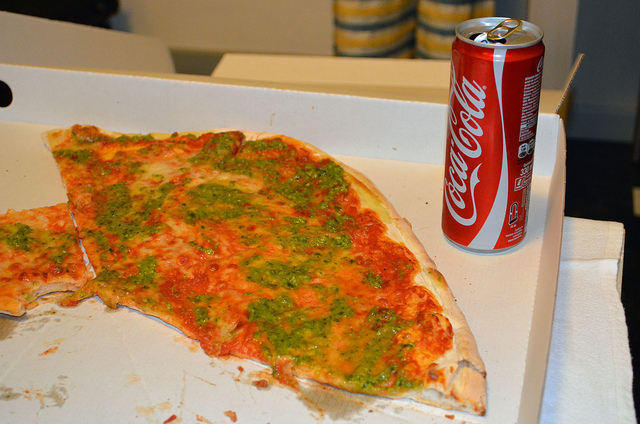Read all the text in this image. CocalCola 